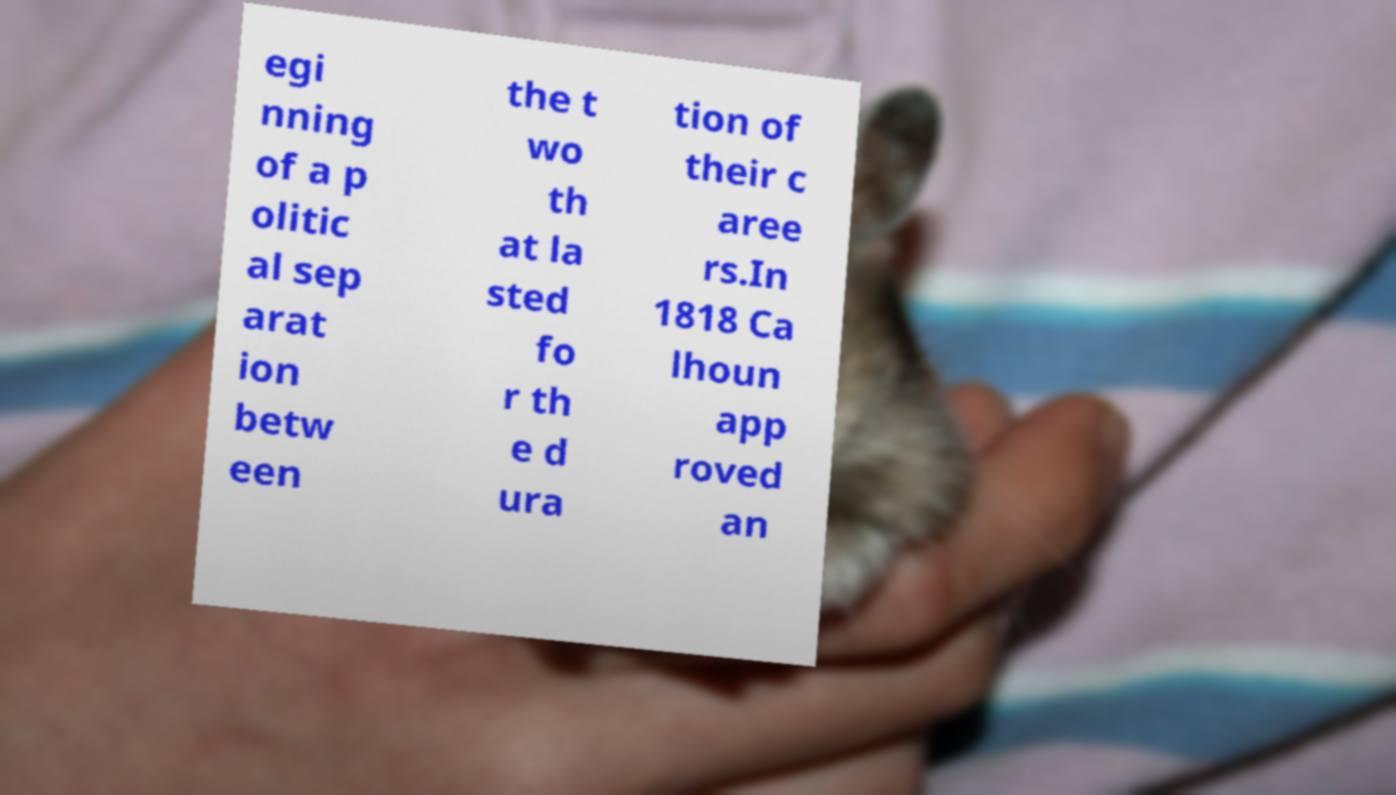What messages or text are displayed in this image? I need them in a readable, typed format. egi nning of a p olitic al sep arat ion betw een the t wo th at la sted fo r th e d ura tion of their c aree rs.In 1818 Ca lhoun app roved an 